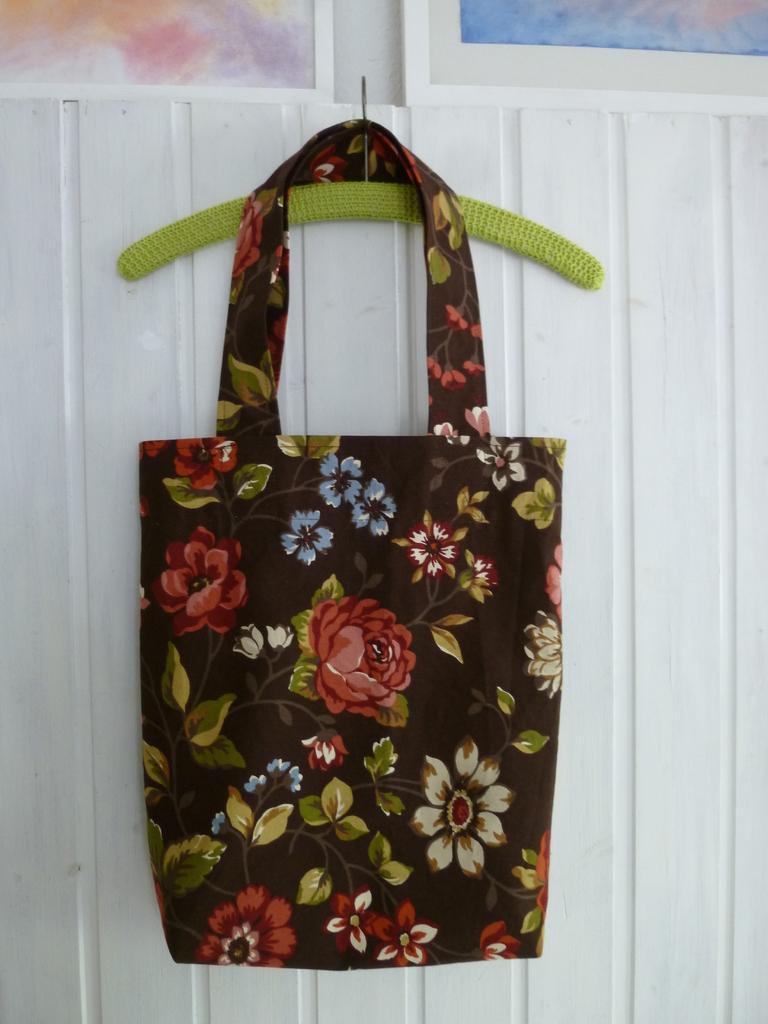Describe this image in one or two sentences. In the image we can see there is a bag which is hanging to the pin on the wall. The wall is of white colour and the bag is black colour and flowers are printed on it. 